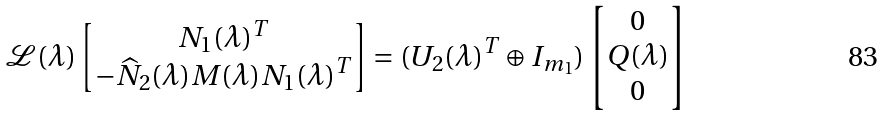<formula> <loc_0><loc_0><loc_500><loc_500>\mathcal { L } ( \lambda ) \begin{bmatrix} N _ { 1 } ( \lambda ) ^ { T } \\ - \widehat { N } _ { 2 } ( \lambda ) M ( \lambda ) N _ { 1 } ( \lambda ) ^ { T } \end{bmatrix} = ( U _ { 2 } ( \lambda ) ^ { T } \oplus I _ { m _ { 1 } } ) \begin{bmatrix} 0 \\ Q ( \lambda ) \\ 0 \end{bmatrix}</formula> 